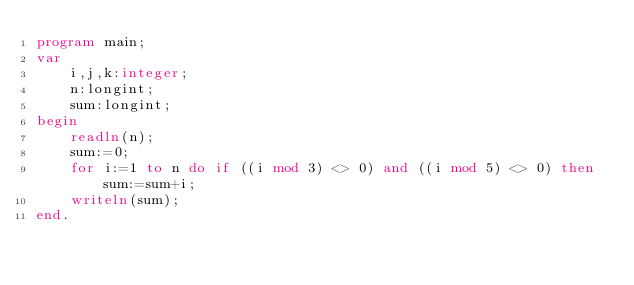<code> <loc_0><loc_0><loc_500><loc_500><_Pascal_>program main;
var
    i,j,k:integer;
    n:longint;
    sum:longint;
begin
    readln(n);
    sum:=0;
    for i:=1 to n do if ((i mod 3) <> 0) and ((i mod 5) <> 0) then sum:=sum+i;
    writeln(sum);
end.</code> 